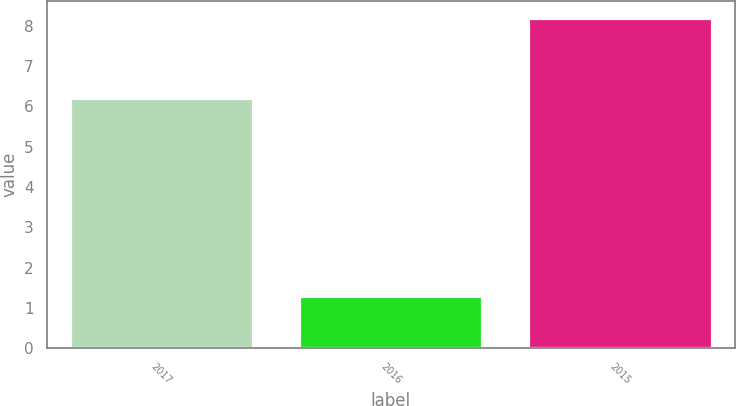Convert chart to OTSL. <chart><loc_0><loc_0><loc_500><loc_500><bar_chart><fcel>2017<fcel>2016<fcel>2015<nl><fcel>6.2<fcel>1.3<fcel>8.2<nl></chart> 